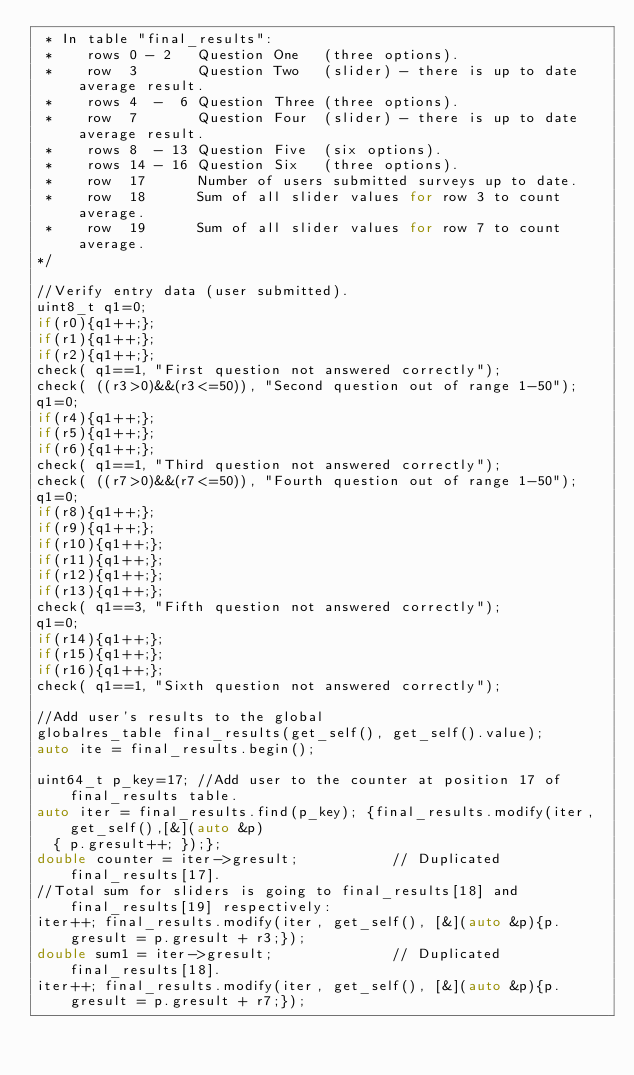<code> <loc_0><loc_0><loc_500><loc_500><_C++_> * In table "final_results": 
 *    rows 0 - 2   Question One   (three options).
 *    row  3       Question Two   (slider) - there is up to date average result.
 *    rows 4  -  6 Question Three (three options).
 *    row  7       Question Four  (slider) - there is up to date average result.
 *    rows 8  - 13 Question Five  (six options).
 *    rows 14 - 16 Question Six   (three options).
 *    row  17      Number of users submitted surveys up to date.
 *    row  18      Sum of all slider values for row 3 to count average.
 *    row  19      Sum of all slider values for row 7 to count average.  
*/  

//Verify entry data (user submitted).
uint8_t q1=0;
if(r0){q1++;};
if(r1){q1++;};
if(r2){q1++;};
check( q1==1, "First question not answered correctly");
check( ((r3>0)&&(r3<=50)), "Second question out of range 1-50");
q1=0;
if(r4){q1++;};
if(r5){q1++;};
if(r6){q1++;};
check( q1==1, "Third question not answered correctly");
check( ((r7>0)&&(r7<=50)), "Fourth question out of range 1-50");
q1=0;
if(r8){q1++;};
if(r9){q1++;};
if(r10){q1++;};
if(r11){q1++;};
if(r12){q1++;};
if(r13){q1++;};
check( q1==3, "Fifth question not answered correctly");
q1=0;
if(r14){q1++;};
if(r15){q1++;};
if(r16){q1++;};
check( q1==1, "Sixth question not answered correctly");

//Add user's results to the global
globalres_table final_results(get_self(), get_self().value);
auto ite = final_results.begin(); 

uint64_t p_key=17; //Add user to the counter at position 17 of final_results table.
auto iter = final_results.find(p_key); {final_results.modify(iter, get_self(),[&](auto &p)
  { p.gresult++; });};  
double counter = iter->gresult;           // Duplicated final_results[17].
//Total sum for sliders is going to final_results[18] and final_results[19] respectively:
iter++; final_results.modify(iter, get_self(), [&](auto &p){p.gresult = p.gresult + r3;});
double sum1 = iter->gresult;              // Duplicated final_results[18].
iter++; final_results.modify(iter, get_self(), [&](auto &p){p.gresult = p.gresult + r7;});</code> 